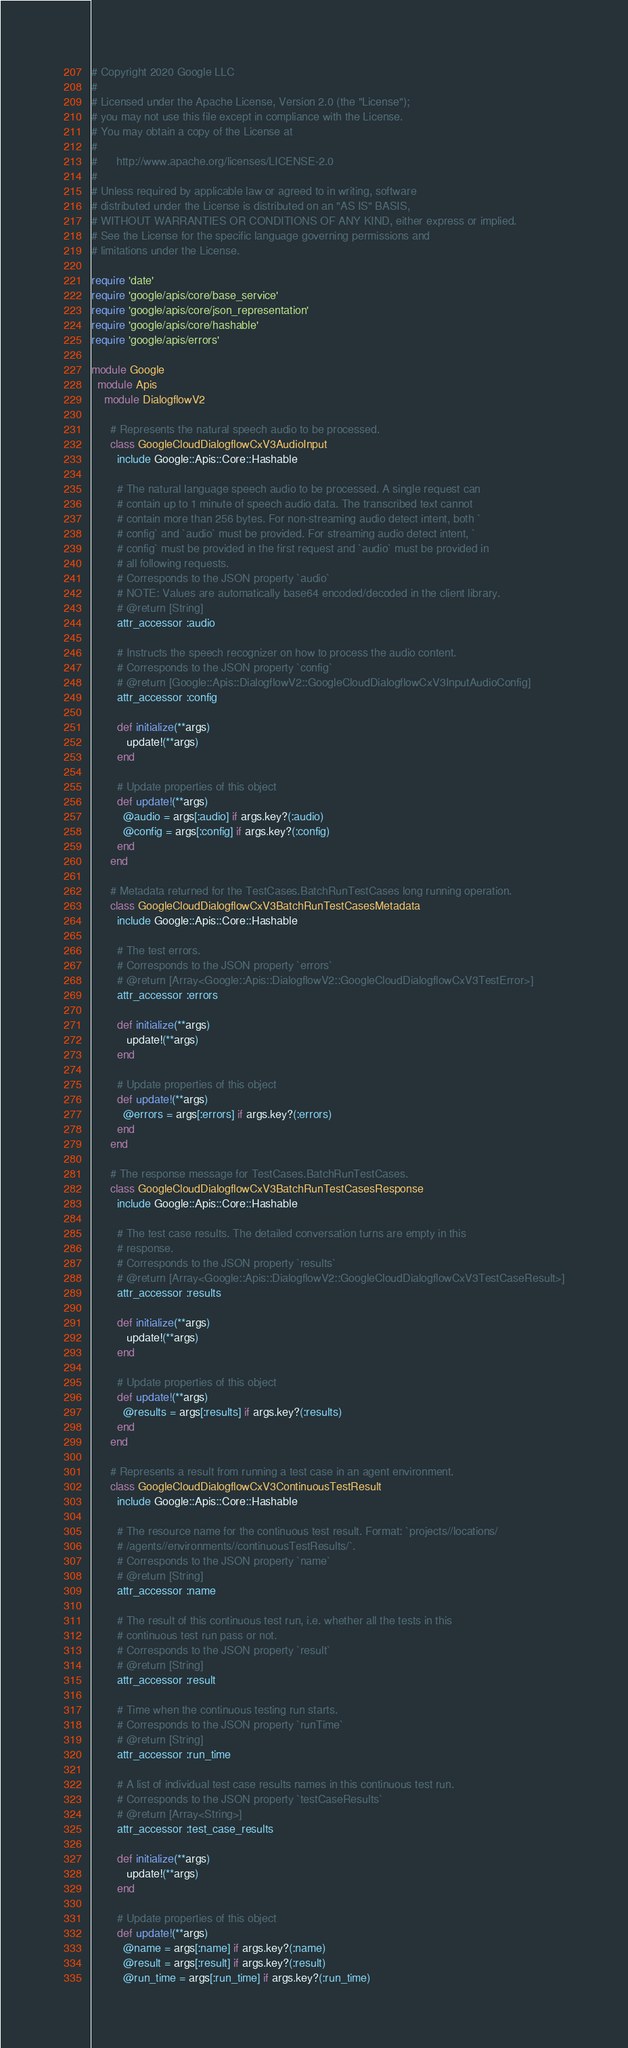<code> <loc_0><loc_0><loc_500><loc_500><_Ruby_># Copyright 2020 Google LLC
#
# Licensed under the Apache License, Version 2.0 (the "License");
# you may not use this file except in compliance with the License.
# You may obtain a copy of the License at
#
#      http://www.apache.org/licenses/LICENSE-2.0
#
# Unless required by applicable law or agreed to in writing, software
# distributed under the License is distributed on an "AS IS" BASIS,
# WITHOUT WARRANTIES OR CONDITIONS OF ANY KIND, either express or implied.
# See the License for the specific language governing permissions and
# limitations under the License.

require 'date'
require 'google/apis/core/base_service'
require 'google/apis/core/json_representation'
require 'google/apis/core/hashable'
require 'google/apis/errors'

module Google
  module Apis
    module DialogflowV2
      
      # Represents the natural speech audio to be processed.
      class GoogleCloudDialogflowCxV3AudioInput
        include Google::Apis::Core::Hashable
      
        # The natural language speech audio to be processed. A single request can
        # contain up to 1 minute of speech audio data. The transcribed text cannot
        # contain more than 256 bytes. For non-streaming audio detect intent, both `
        # config` and `audio` must be provided. For streaming audio detect intent, `
        # config` must be provided in the first request and `audio` must be provided in
        # all following requests.
        # Corresponds to the JSON property `audio`
        # NOTE: Values are automatically base64 encoded/decoded in the client library.
        # @return [String]
        attr_accessor :audio
      
        # Instructs the speech recognizer on how to process the audio content.
        # Corresponds to the JSON property `config`
        # @return [Google::Apis::DialogflowV2::GoogleCloudDialogflowCxV3InputAudioConfig]
        attr_accessor :config
      
        def initialize(**args)
           update!(**args)
        end
      
        # Update properties of this object
        def update!(**args)
          @audio = args[:audio] if args.key?(:audio)
          @config = args[:config] if args.key?(:config)
        end
      end
      
      # Metadata returned for the TestCases.BatchRunTestCases long running operation.
      class GoogleCloudDialogflowCxV3BatchRunTestCasesMetadata
        include Google::Apis::Core::Hashable
      
        # The test errors.
        # Corresponds to the JSON property `errors`
        # @return [Array<Google::Apis::DialogflowV2::GoogleCloudDialogflowCxV3TestError>]
        attr_accessor :errors
      
        def initialize(**args)
           update!(**args)
        end
      
        # Update properties of this object
        def update!(**args)
          @errors = args[:errors] if args.key?(:errors)
        end
      end
      
      # The response message for TestCases.BatchRunTestCases.
      class GoogleCloudDialogflowCxV3BatchRunTestCasesResponse
        include Google::Apis::Core::Hashable
      
        # The test case results. The detailed conversation turns are empty in this
        # response.
        # Corresponds to the JSON property `results`
        # @return [Array<Google::Apis::DialogflowV2::GoogleCloudDialogflowCxV3TestCaseResult>]
        attr_accessor :results
      
        def initialize(**args)
           update!(**args)
        end
      
        # Update properties of this object
        def update!(**args)
          @results = args[:results] if args.key?(:results)
        end
      end
      
      # Represents a result from running a test case in an agent environment.
      class GoogleCloudDialogflowCxV3ContinuousTestResult
        include Google::Apis::Core::Hashable
      
        # The resource name for the continuous test result. Format: `projects//locations/
        # /agents//environments//continuousTestResults/`.
        # Corresponds to the JSON property `name`
        # @return [String]
        attr_accessor :name
      
        # The result of this continuous test run, i.e. whether all the tests in this
        # continuous test run pass or not.
        # Corresponds to the JSON property `result`
        # @return [String]
        attr_accessor :result
      
        # Time when the continuous testing run starts.
        # Corresponds to the JSON property `runTime`
        # @return [String]
        attr_accessor :run_time
      
        # A list of individual test case results names in this continuous test run.
        # Corresponds to the JSON property `testCaseResults`
        # @return [Array<String>]
        attr_accessor :test_case_results
      
        def initialize(**args)
           update!(**args)
        end
      
        # Update properties of this object
        def update!(**args)
          @name = args[:name] if args.key?(:name)
          @result = args[:result] if args.key?(:result)
          @run_time = args[:run_time] if args.key?(:run_time)</code> 